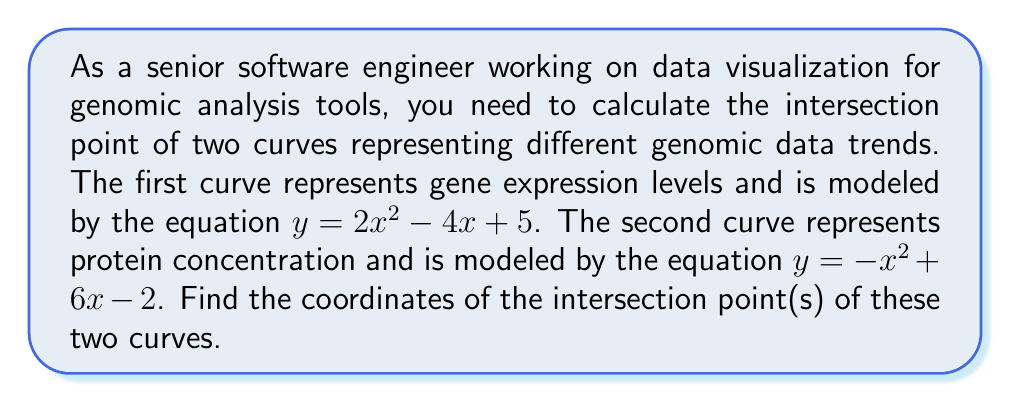Help me with this question. To find the intersection point(s) of the two curves, we need to solve the system of equations:

$$\begin{cases}
y = 2x^2 - 4x + 5 \\
y = -x^2 + 6x - 2
\end{cases}$$

Since both equations are equal to $y$, we can set them equal to each other:

$$2x^2 - 4x + 5 = -x^2 + 6x - 2$$

Rearranging the equation:

$$3x^2 - 10x + 7 = 0$$

This is a quadratic equation in the form $ax^2 + bx + c = 0$, where:
$a = 3$, $b = -10$, and $c = 7$

We can solve this using the quadratic formula: $x = \frac{-b \pm \sqrt{b^2 - 4ac}}{2a}$

Substituting the values:

$$x = \frac{10 \pm \sqrt{(-10)^2 - 4(3)(7)}}{2(3)}$$

$$x = \frac{10 \pm \sqrt{100 - 84}}{6}$$

$$x = \frac{10 \pm \sqrt{16}}{6}$$

$$x = \frac{10 \pm 4}{6}$$

This gives us two solutions:

$$x_1 = \frac{10 + 4}{6} = \frac{14}{6} = \frac{7}{3}$$

$$x_2 = \frac{10 - 4}{6} = \frac{6}{6} = 1$$

To find the corresponding $y$ values, we can substitute these $x$ values into either of the original equations. Let's use the first equation:

For $x_1 = \frac{7}{3}$:
$$y = 2(\frac{7}{3})^2 - 4(\frac{7}{3}) + 5 = \frac{98}{9} - \frac{28}{3} + 5 = \frac{98}{9} - \frac{84}{9} + \frac{45}{9} = \frac{59}{9}$$

For $x_2 = 1$:
$$y = 2(1)^2 - 4(1) + 5 = 2 - 4 + 5 = 3$$

Therefore, the intersection points are $(\frac{7}{3}, \frac{59}{9})$ and $(1, 3)$.
Answer: The intersection points of the two curves are $(\frac{7}{3}, \frac{59}{9})$ and $(1, 3)$. 